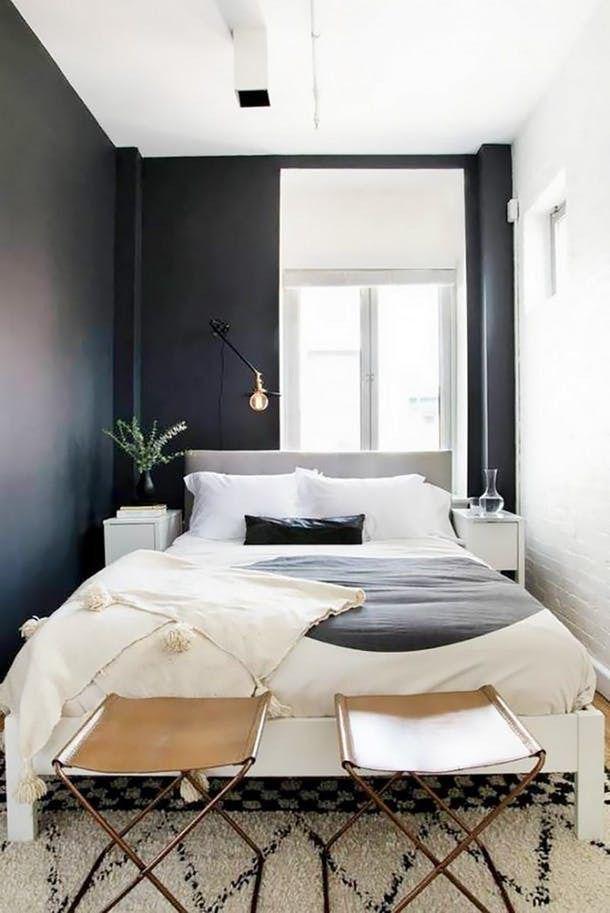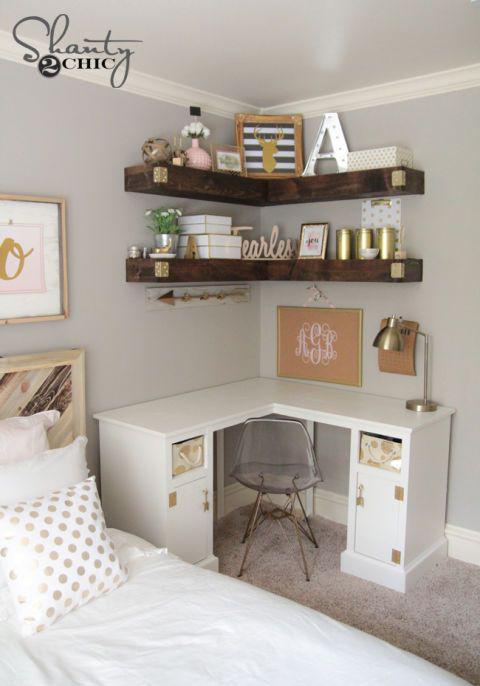The first image is the image on the left, the second image is the image on the right. For the images shown, is this caption "The left image includes a white corner shelf." true? Answer yes or no. No. 